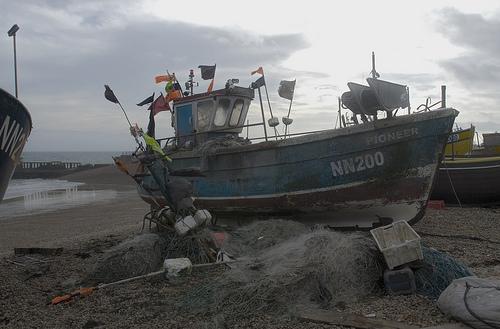How many boats are in focus?
Give a very brief answer. 1. 